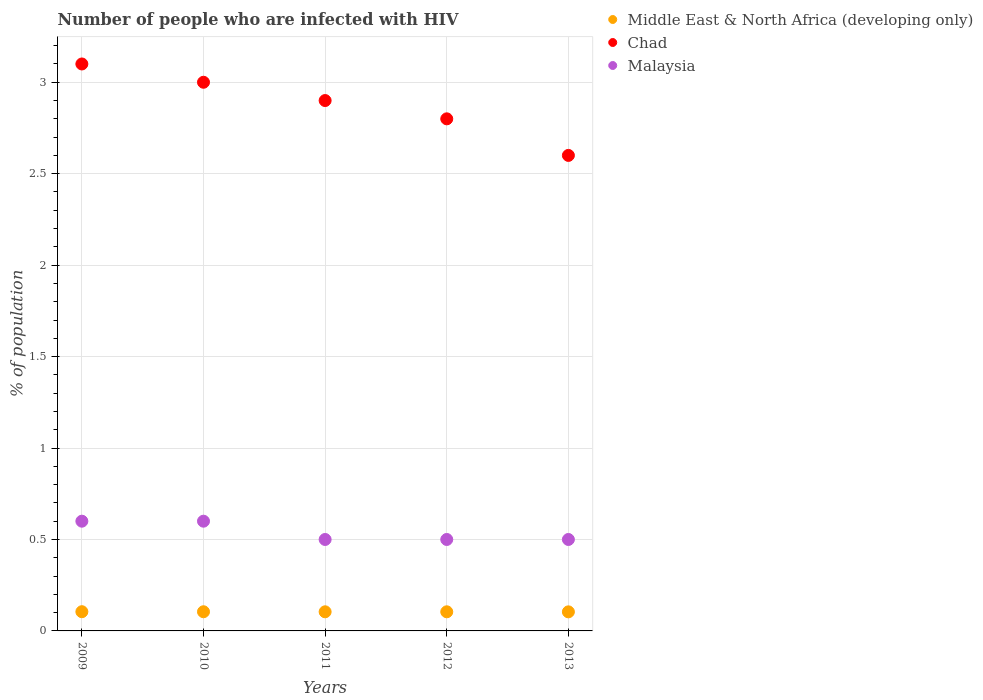How many different coloured dotlines are there?
Provide a succinct answer. 3. Is the number of dotlines equal to the number of legend labels?
Provide a succinct answer. Yes. Across all years, what is the maximum percentage of HIV infected population in in Malaysia?
Offer a very short reply. 0.6. In which year was the percentage of HIV infected population in in Malaysia maximum?
Keep it short and to the point. 2009. In which year was the percentage of HIV infected population in in Middle East & North Africa (developing only) minimum?
Offer a terse response. 2013. What is the total percentage of HIV infected population in in Malaysia in the graph?
Your answer should be compact. 2.7. What is the difference between the percentage of HIV infected population in in Middle East & North Africa (developing only) in 2011 and that in 2012?
Provide a succinct answer. -1.0062197120006e-5. What is the difference between the percentage of HIV infected population in in Malaysia in 2013 and the percentage of HIV infected population in in Chad in 2010?
Ensure brevity in your answer.  -2.5. What is the average percentage of HIV infected population in in Middle East & North Africa (developing only) per year?
Keep it short and to the point. 0.1. In the year 2009, what is the difference between the percentage of HIV infected population in in Malaysia and percentage of HIV infected population in in Middle East & North Africa (developing only)?
Offer a terse response. 0.49. In how many years, is the percentage of HIV infected population in in Middle East & North Africa (developing only) greater than 1 %?
Offer a very short reply. 0. What is the ratio of the percentage of HIV infected population in in Middle East & North Africa (developing only) in 2009 to that in 2012?
Your answer should be compact. 1.01. Is the percentage of HIV infected population in in Middle East & North Africa (developing only) in 2009 less than that in 2010?
Make the answer very short. No. What is the difference between the highest and the second highest percentage of HIV infected population in in Middle East & North Africa (developing only)?
Offer a very short reply. 0. What is the difference between the highest and the lowest percentage of HIV infected population in in Malaysia?
Offer a terse response. 0.1. Is it the case that in every year, the sum of the percentage of HIV infected population in in Malaysia and percentage of HIV infected population in in Chad  is greater than the percentage of HIV infected population in in Middle East & North Africa (developing only)?
Provide a short and direct response. Yes. Is the percentage of HIV infected population in in Chad strictly greater than the percentage of HIV infected population in in Malaysia over the years?
Your answer should be compact. Yes. Is the percentage of HIV infected population in in Middle East & North Africa (developing only) strictly less than the percentage of HIV infected population in in Malaysia over the years?
Offer a very short reply. Yes. How many years are there in the graph?
Provide a succinct answer. 5. What is the difference between two consecutive major ticks on the Y-axis?
Offer a terse response. 0.5. Where does the legend appear in the graph?
Provide a short and direct response. Top right. How are the legend labels stacked?
Your response must be concise. Vertical. What is the title of the graph?
Provide a succinct answer. Number of people who are infected with HIV. What is the label or title of the Y-axis?
Provide a succinct answer. % of population. What is the % of population of Middle East & North Africa (developing only) in 2009?
Provide a succinct answer. 0.11. What is the % of population of Malaysia in 2009?
Ensure brevity in your answer.  0.6. What is the % of population of Middle East & North Africa (developing only) in 2010?
Offer a very short reply. 0.1. What is the % of population in Chad in 2010?
Your answer should be very brief. 3. What is the % of population of Middle East & North Africa (developing only) in 2011?
Give a very brief answer. 0.1. What is the % of population of Middle East & North Africa (developing only) in 2012?
Offer a terse response. 0.1. What is the % of population in Chad in 2012?
Make the answer very short. 2.8. What is the % of population in Malaysia in 2012?
Offer a terse response. 0.5. What is the % of population of Middle East & North Africa (developing only) in 2013?
Provide a succinct answer. 0.1. What is the % of population in Malaysia in 2013?
Offer a terse response. 0.5. Across all years, what is the maximum % of population in Middle East & North Africa (developing only)?
Make the answer very short. 0.11. Across all years, what is the maximum % of population in Chad?
Your response must be concise. 3.1. Across all years, what is the maximum % of population of Malaysia?
Offer a very short reply. 0.6. Across all years, what is the minimum % of population in Middle East & North Africa (developing only)?
Your response must be concise. 0.1. Across all years, what is the minimum % of population in Chad?
Ensure brevity in your answer.  2.6. Across all years, what is the minimum % of population of Malaysia?
Provide a short and direct response. 0.5. What is the total % of population of Middle East & North Africa (developing only) in the graph?
Your response must be concise. 0.52. What is the total % of population in Malaysia in the graph?
Keep it short and to the point. 2.7. What is the difference between the % of population in Middle East & North Africa (developing only) in 2009 and that in 2010?
Offer a very short reply. 0. What is the difference between the % of population in Chad in 2009 and that in 2010?
Ensure brevity in your answer.  0.1. What is the difference between the % of population of Middle East & North Africa (developing only) in 2009 and that in 2011?
Your answer should be very brief. 0. What is the difference between the % of population in Malaysia in 2009 and that in 2011?
Give a very brief answer. 0.1. What is the difference between the % of population of Chad in 2009 and that in 2012?
Keep it short and to the point. 0.3. What is the difference between the % of population in Malaysia in 2009 and that in 2012?
Offer a very short reply. 0.1. What is the difference between the % of population of Middle East & North Africa (developing only) in 2009 and that in 2013?
Provide a succinct answer. 0. What is the difference between the % of population in Chad in 2009 and that in 2013?
Your answer should be compact. 0.5. What is the difference between the % of population in Malaysia in 2009 and that in 2013?
Ensure brevity in your answer.  0.1. What is the difference between the % of population in Middle East & North Africa (developing only) in 2010 and that in 2013?
Offer a terse response. 0. What is the difference between the % of population in Chad in 2010 and that in 2013?
Offer a terse response. 0.4. What is the difference between the % of population in Middle East & North Africa (developing only) in 2012 and that in 2013?
Offer a very short reply. 0. What is the difference between the % of population of Malaysia in 2012 and that in 2013?
Ensure brevity in your answer.  0. What is the difference between the % of population in Middle East & North Africa (developing only) in 2009 and the % of population in Chad in 2010?
Your answer should be compact. -2.89. What is the difference between the % of population in Middle East & North Africa (developing only) in 2009 and the % of population in Malaysia in 2010?
Make the answer very short. -0.49. What is the difference between the % of population in Middle East & North Africa (developing only) in 2009 and the % of population in Chad in 2011?
Your answer should be very brief. -2.79. What is the difference between the % of population in Middle East & North Africa (developing only) in 2009 and the % of population in Malaysia in 2011?
Provide a succinct answer. -0.39. What is the difference between the % of population in Middle East & North Africa (developing only) in 2009 and the % of population in Chad in 2012?
Provide a succinct answer. -2.69. What is the difference between the % of population of Middle East & North Africa (developing only) in 2009 and the % of population of Malaysia in 2012?
Your response must be concise. -0.39. What is the difference between the % of population in Middle East & North Africa (developing only) in 2009 and the % of population in Chad in 2013?
Your answer should be compact. -2.49. What is the difference between the % of population in Middle East & North Africa (developing only) in 2009 and the % of population in Malaysia in 2013?
Keep it short and to the point. -0.39. What is the difference between the % of population of Middle East & North Africa (developing only) in 2010 and the % of population of Chad in 2011?
Offer a terse response. -2.8. What is the difference between the % of population in Middle East & North Africa (developing only) in 2010 and the % of population in Malaysia in 2011?
Offer a terse response. -0.4. What is the difference between the % of population in Middle East & North Africa (developing only) in 2010 and the % of population in Chad in 2012?
Offer a terse response. -2.7. What is the difference between the % of population of Middle East & North Africa (developing only) in 2010 and the % of population of Malaysia in 2012?
Offer a very short reply. -0.4. What is the difference between the % of population of Middle East & North Africa (developing only) in 2010 and the % of population of Chad in 2013?
Provide a short and direct response. -2.5. What is the difference between the % of population in Middle East & North Africa (developing only) in 2010 and the % of population in Malaysia in 2013?
Your response must be concise. -0.4. What is the difference between the % of population in Chad in 2010 and the % of population in Malaysia in 2013?
Provide a short and direct response. 2.5. What is the difference between the % of population of Middle East & North Africa (developing only) in 2011 and the % of population of Chad in 2012?
Provide a succinct answer. -2.7. What is the difference between the % of population of Middle East & North Africa (developing only) in 2011 and the % of population of Malaysia in 2012?
Your response must be concise. -0.4. What is the difference between the % of population in Chad in 2011 and the % of population in Malaysia in 2012?
Your answer should be very brief. 2.4. What is the difference between the % of population of Middle East & North Africa (developing only) in 2011 and the % of population of Chad in 2013?
Provide a short and direct response. -2.5. What is the difference between the % of population in Middle East & North Africa (developing only) in 2011 and the % of population in Malaysia in 2013?
Make the answer very short. -0.4. What is the difference between the % of population in Middle East & North Africa (developing only) in 2012 and the % of population in Chad in 2013?
Give a very brief answer. -2.5. What is the difference between the % of population of Middle East & North Africa (developing only) in 2012 and the % of population of Malaysia in 2013?
Ensure brevity in your answer.  -0.4. What is the average % of population in Middle East & North Africa (developing only) per year?
Keep it short and to the point. 0.1. What is the average % of population in Chad per year?
Provide a succinct answer. 2.88. What is the average % of population in Malaysia per year?
Keep it short and to the point. 0.54. In the year 2009, what is the difference between the % of population of Middle East & North Africa (developing only) and % of population of Chad?
Your answer should be compact. -2.99. In the year 2009, what is the difference between the % of population of Middle East & North Africa (developing only) and % of population of Malaysia?
Your response must be concise. -0.49. In the year 2009, what is the difference between the % of population of Chad and % of population of Malaysia?
Provide a short and direct response. 2.5. In the year 2010, what is the difference between the % of population in Middle East & North Africa (developing only) and % of population in Chad?
Offer a very short reply. -2.9. In the year 2010, what is the difference between the % of population in Middle East & North Africa (developing only) and % of population in Malaysia?
Your answer should be very brief. -0.5. In the year 2010, what is the difference between the % of population of Chad and % of population of Malaysia?
Provide a succinct answer. 2.4. In the year 2011, what is the difference between the % of population of Middle East & North Africa (developing only) and % of population of Chad?
Your answer should be compact. -2.8. In the year 2011, what is the difference between the % of population of Middle East & North Africa (developing only) and % of population of Malaysia?
Your answer should be compact. -0.4. In the year 2012, what is the difference between the % of population in Middle East & North Africa (developing only) and % of population in Chad?
Provide a short and direct response. -2.7. In the year 2012, what is the difference between the % of population of Middle East & North Africa (developing only) and % of population of Malaysia?
Ensure brevity in your answer.  -0.4. In the year 2013, what is the difference between the % of population of Middle East & North Africa (developing only) and % of population of Chad?
Give a very brief answer. -2.5. In the year 2013, what is the difference between the % of population in Middle East & North Africa (developing only) and % of population in Malaysia?
Give a very brief answer. -0.4. In the year 2013, what is the difference between the % of population of Chad and % of population of Malaysia?
Offer a terse response. 2.1. What is the ratio of the % of population of Malaysia in 2009 to that in 2010?
Provide a succinct answer. 1. What is the ratio of the % of population of Middle East & North Africa (developing only) in 2009 to that in 2011?
Ensure brevity in your answer.  1.01. What is the ratio of the % of population of Chad in 2009 to that in 2011?
Offer a terse response. 1.07. What is the ratio of the % of population of Middle East & North Africa (developing only) in 2009 to that in 2012?
Give a very brief answer. 1. What is the ratio of the % of population in Chad in 2009 to that in 2012?
Provide a succinct answer. 1.11. What is the ratio of the % of population of Malaysia in 2009 to that in 2012?
Keep it short and to the point. 1.2. What is the ratio of the % of population in Middle East & North Africa (developing only) in 2009 to that in 2013?
Your response must be concise. 1.01. What is the ratio of the % of population of Chad in 2009 to that in 2013?
Provide a short and direct response. 1.19. What is the ratio of the % of population of Malaysia in 2009 to that in 2013?
Provide a succinct answer. 1.2. What is the ratio of the % of population of Chad in 2010 to that in 2011?
Give a very brief answer. 1.03. What is the ratio of the % of population in Middle East & North Africa (developing only) in 2010 to that in 2012?
Offer a very short reply. 1. What is the ratio of the % of population of Chad in 2010 to that in 2012?
Offer a very short reply. 1.07. What is the ratio of the % of population of Malaysia in 2010 to that in 2012?
Keep it short and to the point. 1.2. What is the ratio of the % of population of Chad in 2010 to that in 2013?
Give a very brief answer. 1.15. What is the ratio of the % of population in Middle East & North Africa (developing only) in 2011 to that in 2012?
Your answer should be very brief. 1. What is the ratio of the % of population in Chad in 2011 to that in 2012?
Give a very brief answer. 1.04. What is the ratio of the % of population in Chad in 2011 to that in 2013?
Make the answer very short. 1.12. What is the ratio of the % of population of Malaysia in 2011 to that in 2013?
Provide a short and direct response. 1. What is the ratio of the % of population of Middle East & North Africa (developing only) in 2012 to that in 2013?
Your answer should be very brief. 1. What is the ratio of the % of population in Chad in 2012 to that in 2013?
Provide a short and direct response. 1.08. What is the difference between the highest and the second highest % of population of Chad?
Provide a short and direct response. 0.1. What is the difference between the highest and the lowest % of population in Middle East & North Africa (developing only)?
Your answer should be compact. 0. What is the difference between the highest and the lowest % of population of Chad?
Offer a terse response. 0.5. What is the difference between the highest and the lowest % of population of Malaysia?
Ensure brevity in your answer.  0.1. 